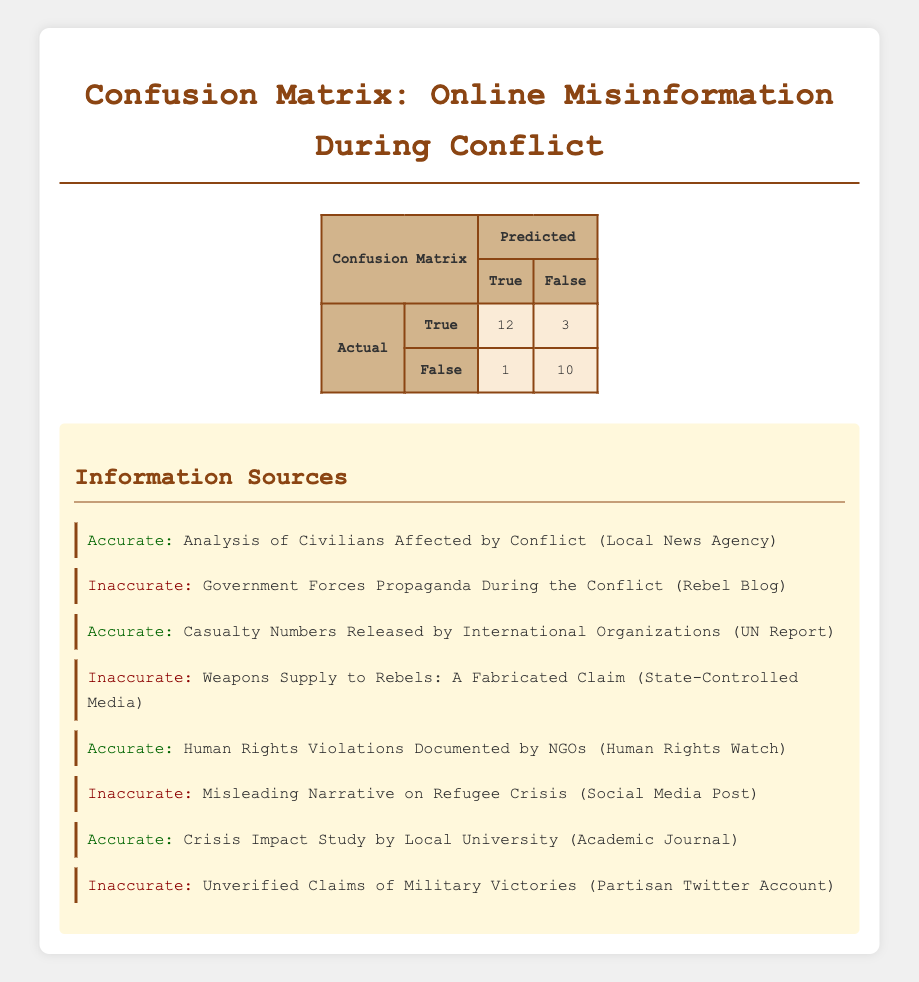What are the total predictions for true information? To find the total predictions for true information, we look at the "Predicted" row for "True" which sums the values: accurate (12) + inaccurate (1) = 13.
Answer: 13 What is the number of actual accurate information predictions? We can find this by checking the "Actual" row for "True" which indicates the number of accurate predictions is 12.
Answer: 12 How many total predictions were made for inaccurate information? The total predictions for inaccurate information can be found by adding the numbers in the "False" row under "Predicted": accurate (3) + inaccurate (10) = 13.
Answer: 13 Is the number of actual accurate predictions greater than the number of actual inaccurate predictions? Comparing the actual accurate predictions (12) with the actual inaccurate predictions (13), we can see that 12 is not greater than 13. Hence, the statement is false.
Answer: No What is the total number of predictions made, regardless of accuracy? We can sum all predictions in the confusion matrix: (12 + 3) + (1 + 10) = 26. This includes all true and false predictions.
Answer: 26 What percentage of the actual information predicted as true was accurate? To find the percentage, we take the number of accurate true predictions (12) and divide it by the total number of true predictions (13), then multiply by 100: (12/13) * 100 ≈ 92.31%.
Answer: Approximately 92.31% What is the difference between the actual number of inaccurate predictions and the predicted number for false information? We subtract the predicted inaccuracy for "False" (10) from the actual inaccuracy (3); this results in a difference of 3 - 10 = -7, indicating there were more false predictions than actual inaccuracies.
Answer: -7 How many actual true predictions were incorrectly identified as inaccurate? From the table, we see that there is 1 actual true prediction that was misclassified as false (predicted inaccurate).
Answer: 1 What is the ratio of accurate predictions to inaccurate predictions in the actual outcomes? To determine the ratio of accurate predictions (12) to inaccurate predictions (13), we express this as a fraction: 12:13. This indicates there are slightly fewer accurate predictions than inaccurate ones.
Answer: 12:13 